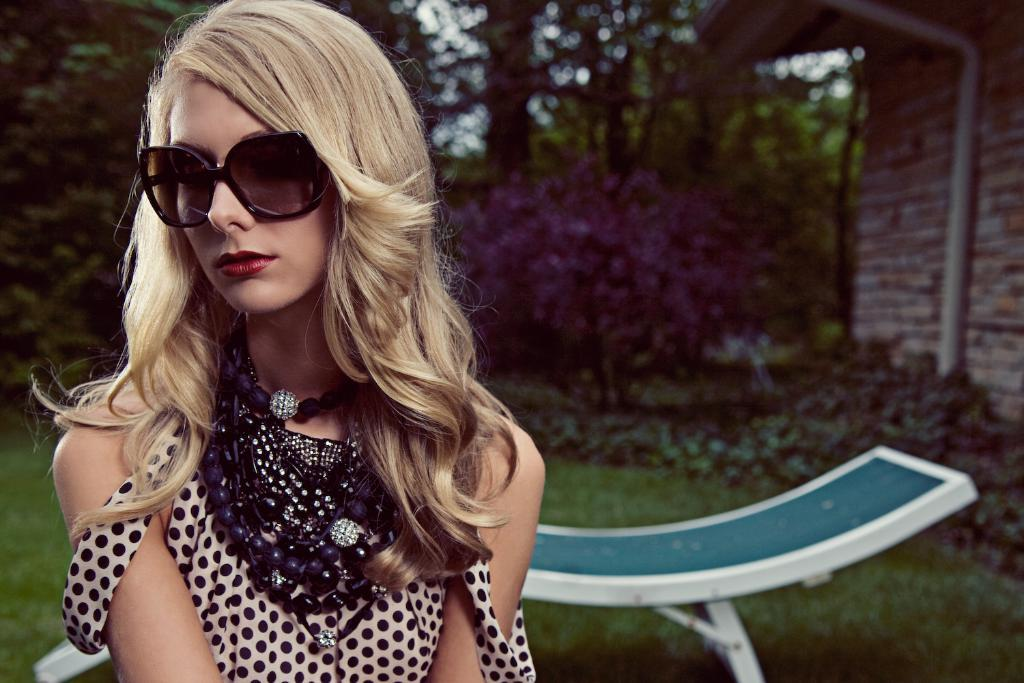Who is present in the image? There is a woman in the image. What accessory is the woman wearing? The woman is wearing glasses. What type of natural environment is visible in the image? There is grass, plants, and trees visible in the image. What type of seating is present in the image? There is a bench in the image. What type of structure is visible in the image? There is a house in the image. What type of machine is visible in the woman's pocket in the image? There is no machine visible in the woman's pocket in the image, as the facts provided do not mention any machines or pockets. 